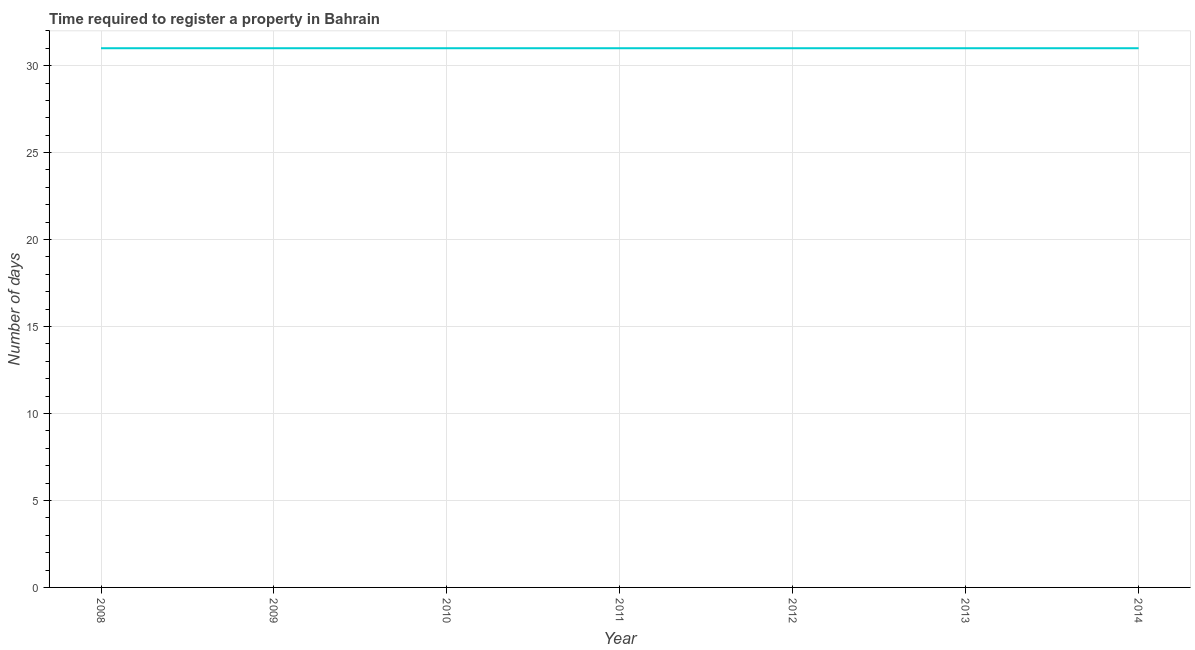What is the number of days required to register property in 2009?
Your answer should be compact. 31. Across all years, what is the maximum number of days required to register property?
Offer a very short reply. 31. Across all years, what is the minimum number of days required to register property?
Provide a succinct answer. 31. In which year was the number of days required to register property maximum?
Your response must be concise. 2008. In which year was the number of days required to register property minimum?
Offer a very short reply. 2008. What is the sum of the number of days required to register property?
Ensure brevity in your answer.  217. What is the median number of days required to register property?
Offer a very short reply. 31. Do a majority of the years between 2009 and 2011 (inclusive) have number of days required to register property greater than 11 days?
Offer a very short reply. Yes. What is the ratio of the number of days required to register property in 2008 to that in 2013?
Your response must be concise. 1. Is the difference between the number of days required to register property in 2009 and 2011 greater than the difference between any two years?
Keep it short and to the point. Yes. What is the difference between the highest and the second highest number of days required to register property?
Offer a terse response. 0. Does the number of days required to register property monotonically increase over the years?
Provide a short and direct response. No. Are the values on the major ticks of Y-axis written in scientific E-notation?
Provide a short and direct response. No. Does the graph contain grids?
Provide a short and direct response. Yes. What is the title of the graph?
Provide a succinct answer. Time required to register a property in Bahrain. What is the label or title of the Y-axis?
Your answer should be compact. Number of days. What is the Number of days of 2009?
Offer a terse response. 31. What is the Number of days of 2011?
Ensure brevity in your answer.  31. What is the Number of days of 2012?
Give a very brief answer. 31. What is the Number of days of 2013?
Make the answer very short. 31. What is the Number of days in 2014?
Keep it short and to the point. 31. What is the difference between the Number of days in 2008 and 2010?
Offer a terse response. 0. What is the difference between the Number of days in 2008 and 2011?
Your answer should be very brief. 0. What is the difference between the Number of days in 2008 and 2012?
Provide a succinct answer. 0. What is the difference between the Number of days in 2008 and 2013?
Offer a very short reply. 0. What is the difference between the Number of days in 2008 and 2014?
Your response must be concise. 0. What is the difference between the Number of days in 2009 and 2012?
Give a very brief answer. 0. What is the difference between the Number of days in 2009 and 2014?
Ensure brevity in your answer.  0. What is the difference between the Number of days in 2010 and 2012?
Make the answer very short. 0. What is the difference between the Number of days in 2010 and 2014?
Your response must be concise. 0. What is the difference between the Number of days in 2011 and 2013?
Make the answer very short. 0. What is the difference between the Number of days in 2012 and 2013?
Offer a very short reply. 0. What is the difference between the Number of days in 2013 and 2014?
Make the answer very short. 0. What is the ratio of the Number of days in 2008 to that in 2009?
Your answer should be very brief. 1. What is the ratio of the Number of days in 2008 to that in 2011?
Your answer should be compact. 1. What is the ratio of the Number of days in 2008 to that in 2012?
Your answer should be very brief. 1. What is the ratio of the Number of days in 2009 to that in 2010?
Your response must be concise. 1. What is the ratio of the Number of days in 2009 to that in 2011?
Your answer should be compact. 1. What is the ratio of the Number of days in 2009 to that in 2014?
Provide a short and direct response. 1. What is the ratio of the Number of days in 2010 to that in 2012?
Provide a short and direct response. 1. What is the ratio of the Number of days in 2010 to that in 2013?
Give a very brief answer. 1. What is the ratio of the Number of days in 2011 to that in 2012?
Offer a terse response. 1. What is the ratio of the Number of days in 2012 to that in 2014?
Keep it short and to the point. 1. 